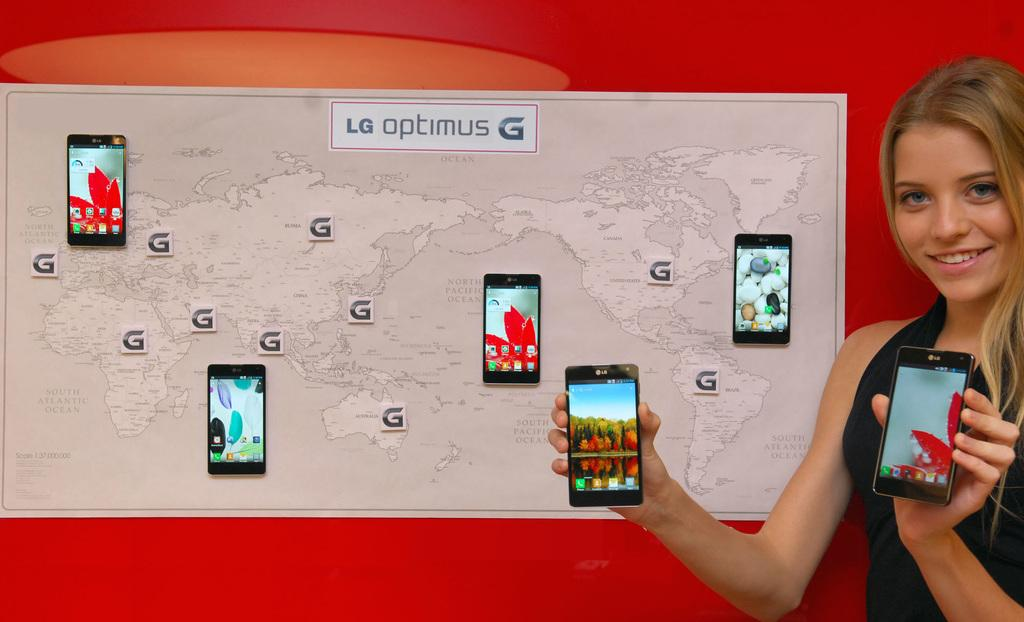Who is present in the image? There is a woman in the image. What is the woman holding in the image? The woman is holding mobile phones. What can be seen on the backside of an object in the image? There are pictures of mobile phones and a map visible on the backside. What is written on the paper pasted on the wall? There is text on a paper pasted on the wall. What type of honey is being traded in the image? There is no honey or trade activity present in the image. What is the chance of winning a prize in the image? There is no indication of a prize or chance in the image. 